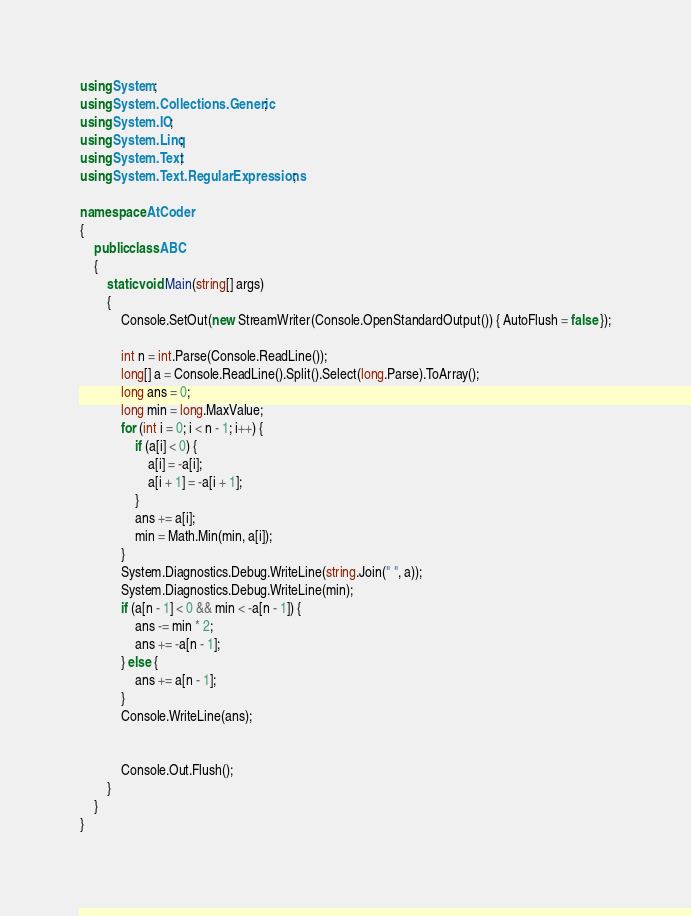Convert code to text. <code><loc_0><loc_0><loc_500><loc_500><_C#_>using System;
using System.Collections.Generic;
using System.IO;
using System.Linq;
using System.Text;
using System.Text.RegularExpressions;

namespace AtCoder
{
	public class ABC
	{
		static void Main(string[] args)
		{
			Console.SetOut(new StreamWriter(Console.OpenStandardOutput()) { AutoFlush = false });

			int n = int.Parse(Console.ReadLine());
			long[] a = Console.ReadLine().Split().Select(long.Parse).ToArray();
			long ans = 0;
			long min = long.MaxValue;
			for (int i = 0; i < n - 1; i++) {
				if (a[i] < 0) {
					a[i] = -a[i];
					a[i + 1] = -a[i + 1];
				}
				ans += a[i];
				min = Math.Min(min, a[i]);
			}
			System.Diagnostics.Debug.WriteLine(string.Join(" ", a));
			System.Diagnostics.Debug.WriteLine(min);
			if (a[n - 1] < 0 && min < -a[n - 1]) {
				ans -= min * 2;
				ans += -a[n - 1];
			} else {
				ans += a[n - 1];
			}
			Console.WriteLine(ans);


			Console.Out.Flush();
		}
	}
}
</code> 